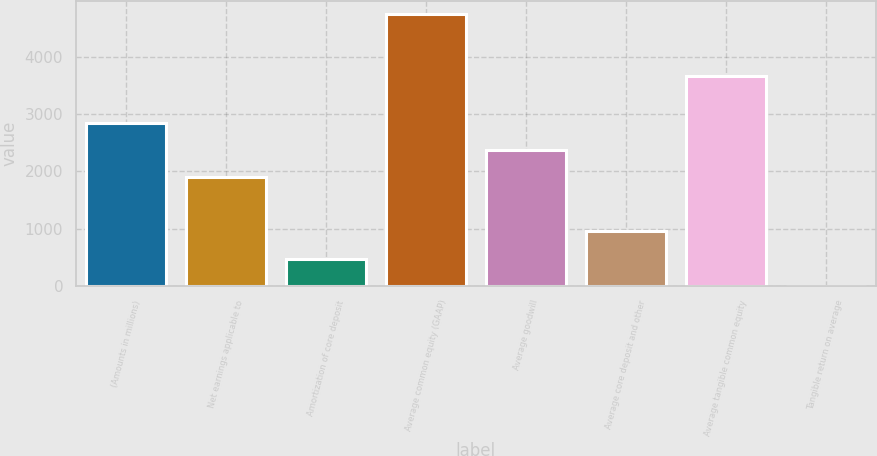Convert chart. <chart><loc_0><loc_0><loc_500><loc_500><bar_chart><fcel>(Amounts in millions)<fcel>Net earnings applicable to<fcel>Amortization of core deposit<fcel>Average common equity (GAAP)<fcel>Average goodwill<fcel>Average core deposit and other<fcel>Average tangible common equity<fcel>Tangible return on average<nl><fcel>2849.06<fcel>1901.1<fcel>479.16<fcel>4745<fcel>2375.08<fcel>953.14<fcel>3671<fcel>5.18<nl></chart> 